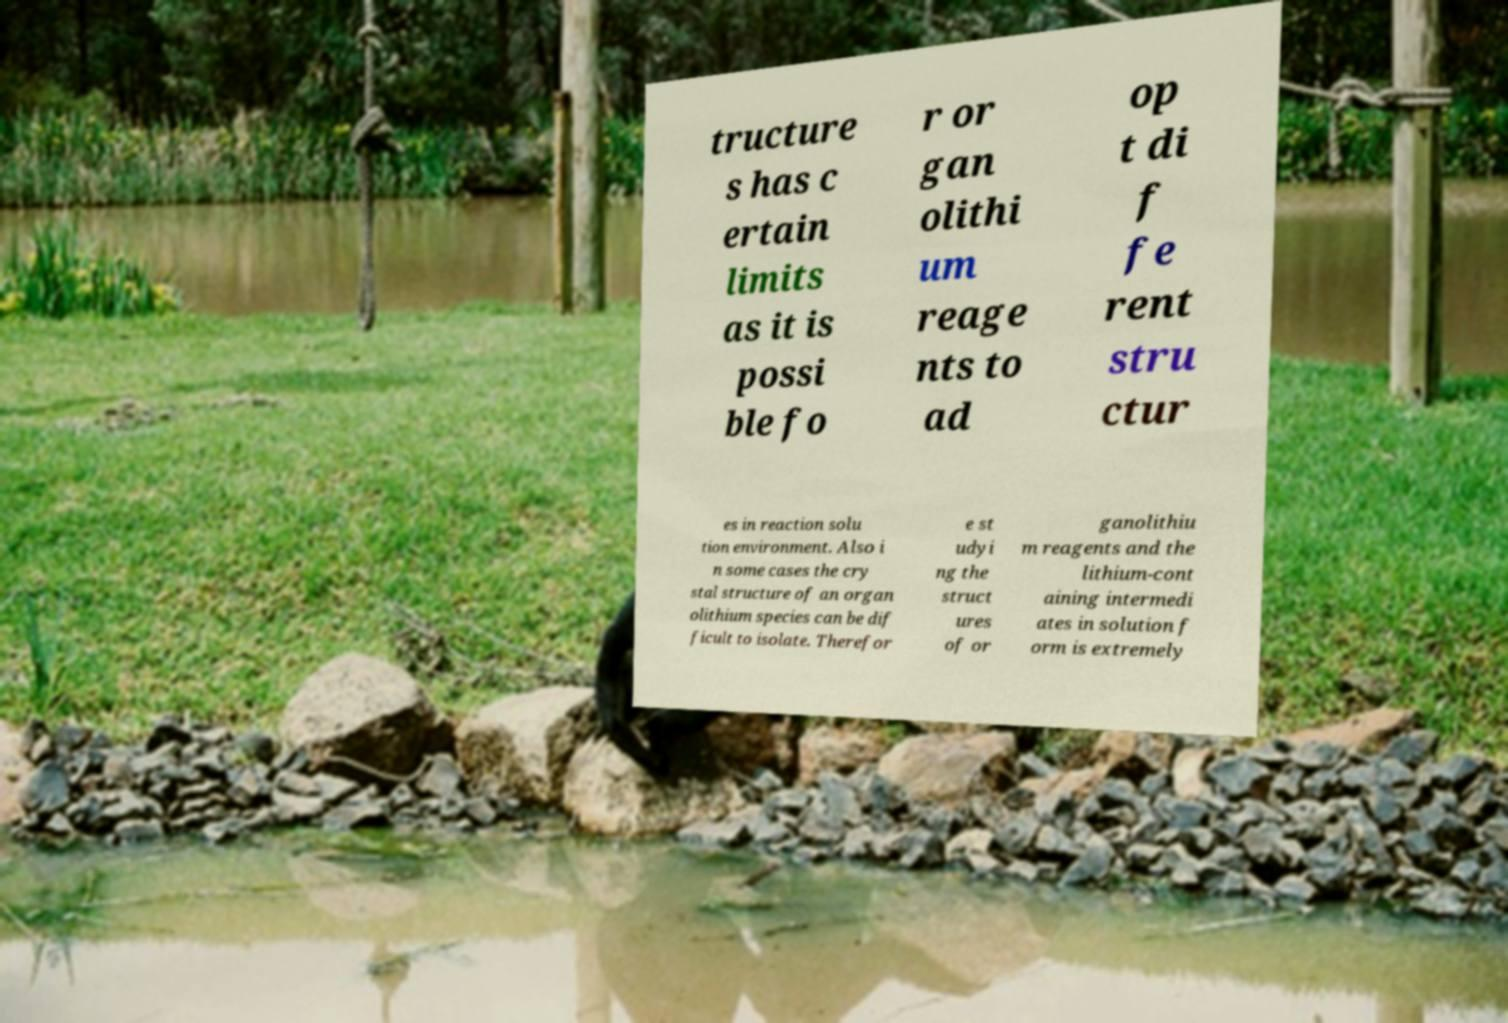Please identify and transcribe the text found in this image. tructure s has c ertain limits as it is possi ble fo r or gan olithi um reage nts to ad op t di f fe rent stru ctur es in reaction solu tion environment. Also i n some cases the cry stal structure of an organ olithium species can be dif ficult to isolate. Therefor e st udyi ng the struct ures of or ganolithiu m reagents and the lithium-cont aining intermedi ates in solution f orm is extremely 